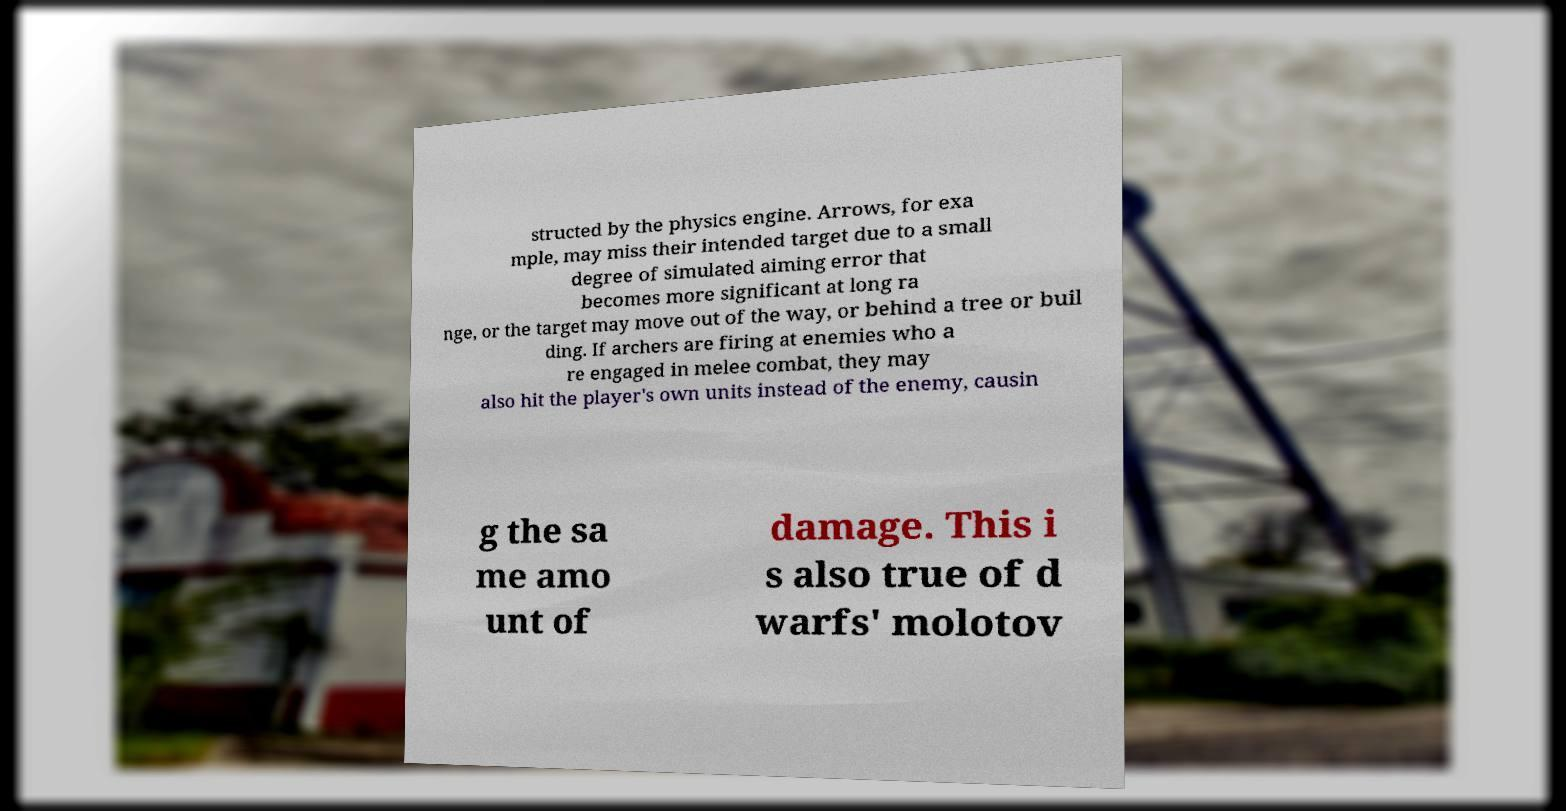I need the written content from this picture converted into text. Can you do that? structed by the physics engine. Arrows, for exa mple, may miss their intended target due to a small degree of simulated aiming error that becomes more significant at long ra nge, or the target may move out of the way, or behind a tree or buil ding. If archers are firing at enemies who a re engaged in melee combat, they may also hit the player's own units instead of the enemy, causin g the sa me amo unt of damage. This i s also true of d warfs' molotov 